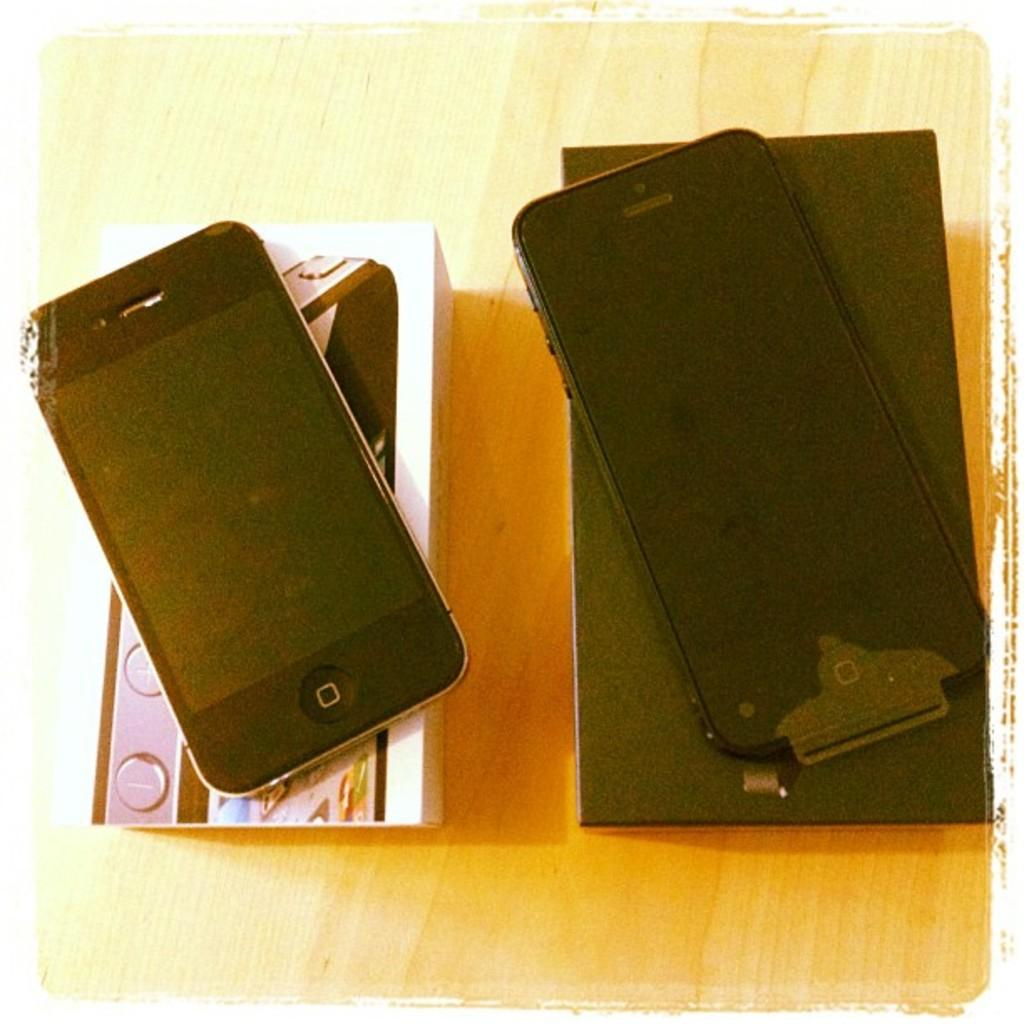What objects are present in the image? There are mobile phones in the image. Where are the mobile phones located? The mobile phones are on boxes. What type of hat is visible on the mobile phones in the image? There is no hat present on the mobile phones in the image. Is there a bath visible in the image? There is no bath present in the image. 